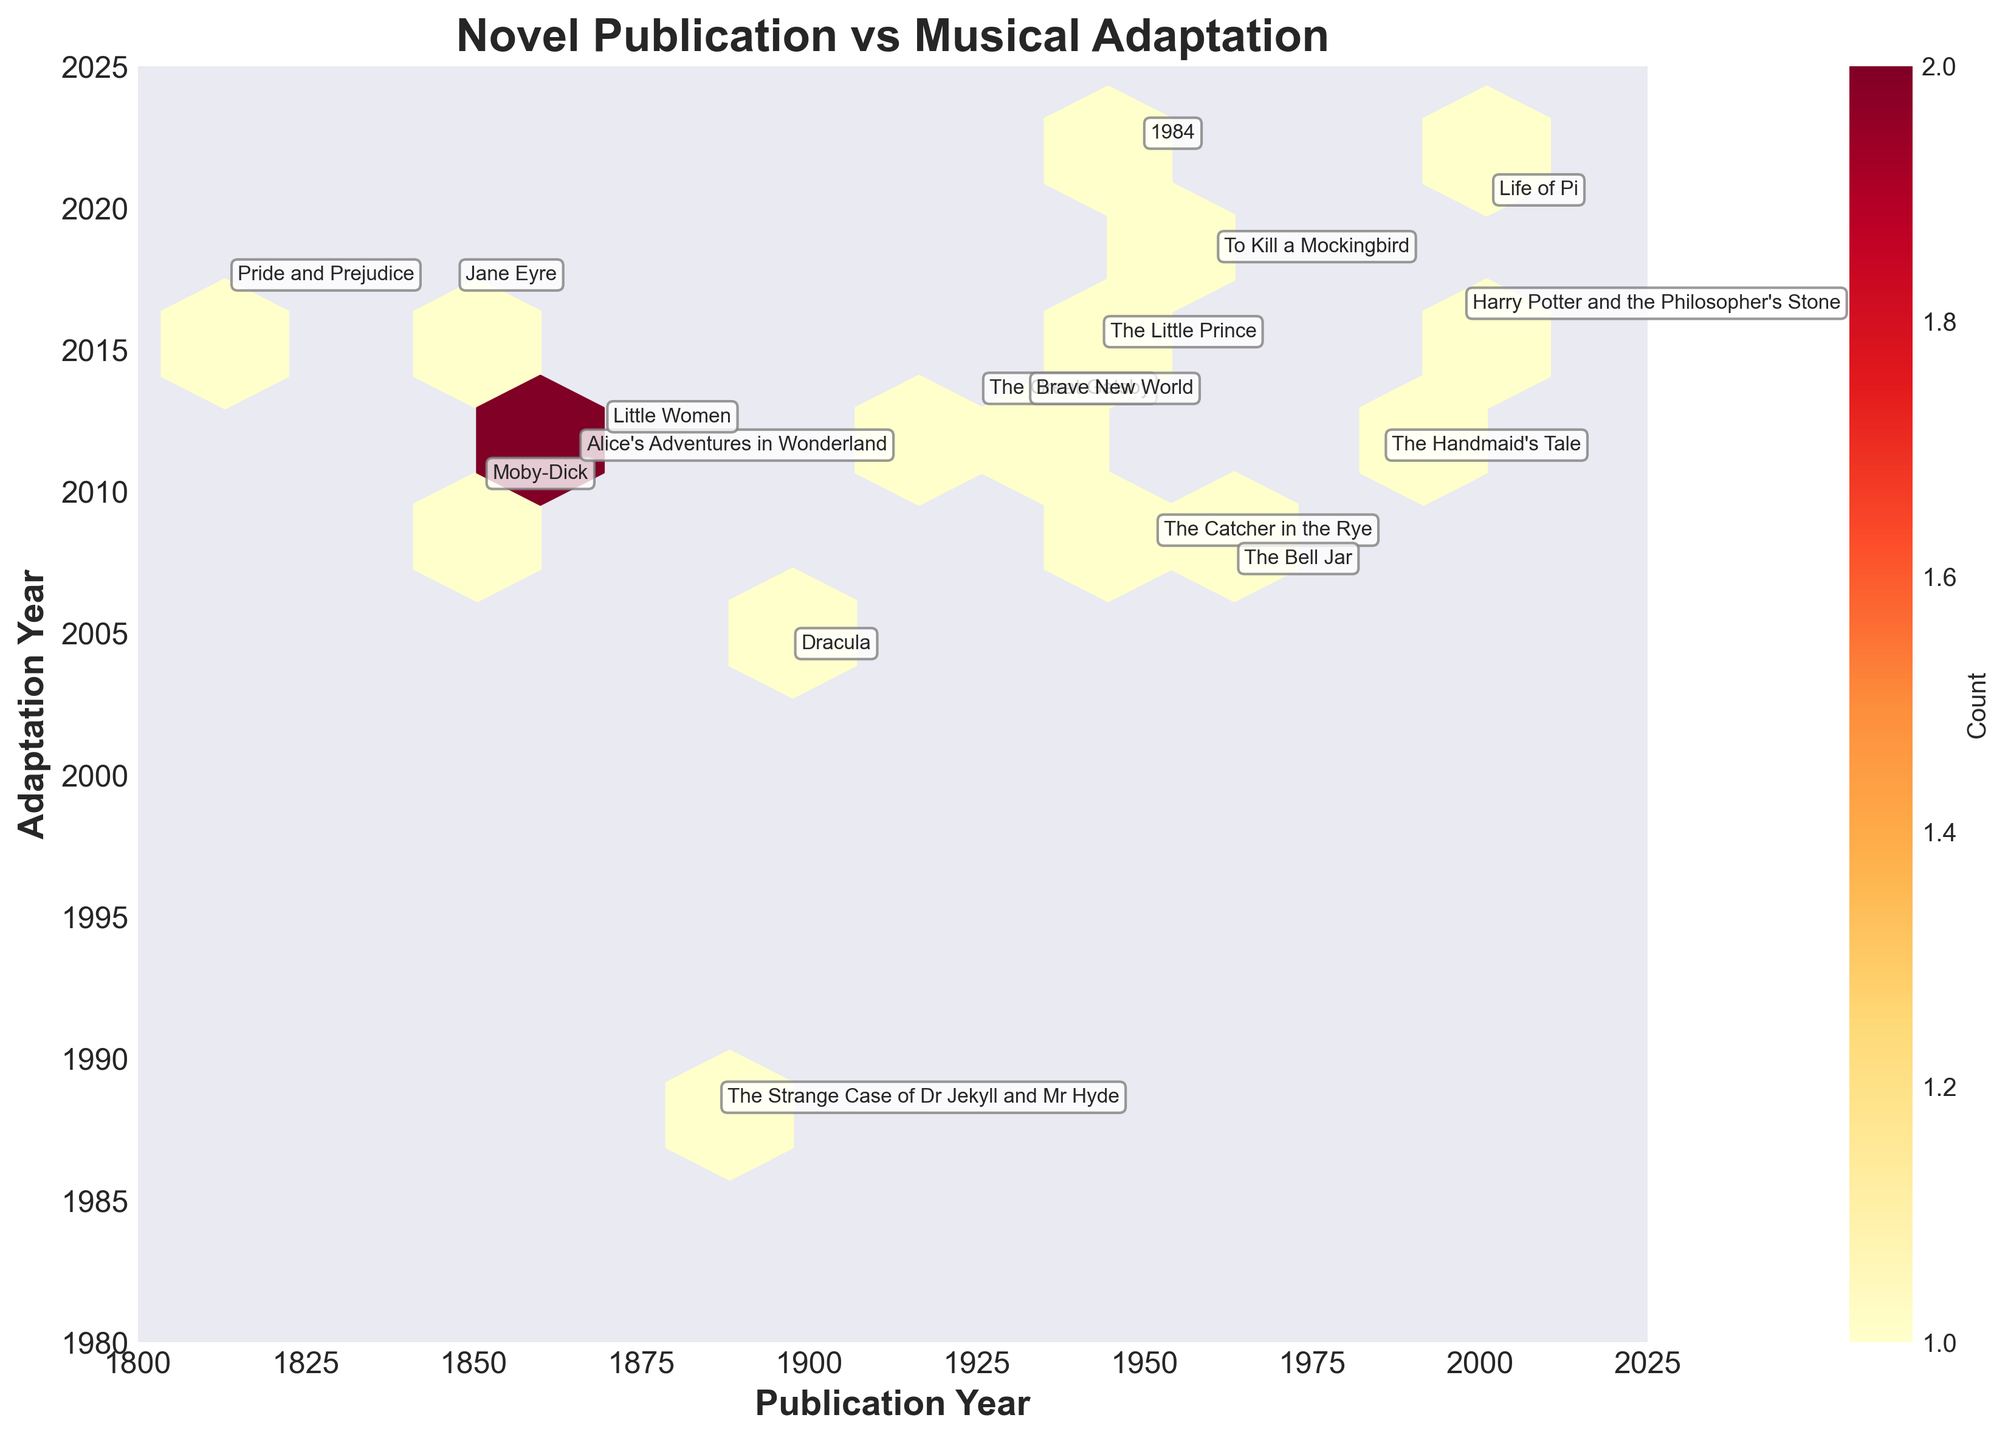What is the title of the hexbin plot? The title of the plot occupies a prominent position above the plot and is typically displayed in a larger, bold font. The title of this specific plot reads "Novel Publication vs Musical Adaptation".
Answer: Novel Publication vs Musical Adaptation How many novels were adapted into musicals in the 21st century? The plot’s y-axis represents the adaptation years. Count the number of data points (hexagons) that fall between the years 2001 and 2023 on the y-axis. There are adaptations for 9 novels in this range.
Answer: 9 Which novel published in the 19th century has the most recent adaptation? Locate the data points for novels published between 1801 and 1900 on the x-axis and check their positions on the y-axis for adaptation years. "Jane Eyre" and "Pride and Prejudice" show the most recent adaptations in 2017.
Answer: Jane Eyre and Pride and Prejudice What is the color of the hexagons representing the highest concentration of data points? The color of each hexagon indicates the density of data points within it, with a color gradient shown in the color bar. The highest concentration typically appears in the darkest colored hexagons, which in this palette would be a dark red.
Answer: Dark red Are there more adaptations done before or after 2010 based on the plot? By observing the distribution of data points along the y-axis, count the number of adaptations before and after 2010. Visual inspection suggests there are more adaptations after 2010.
Answer: After 2010 What is the earliest year a novel from the plot was adapted into a musical? By checking the lower bounds of the y-axis, determine the earliest year shown among the data points. The earliest adaptation year from the plot data is 1988 for "The Strange Case of Dr Jekyll and Mr Hyde".
Answer: 1988 How long did it take on average for the 19th-century novels to be adapted into musicals? Identify the novels published between 1801 and 1900, subtract their publication years from their respective adaptation years, then average these differences. (e.g., 2017-1813 = 204 for "Pride and Prejudice", 2004-1897 = 107 for "Dracula", etc.). A detailed calculation is necessary based on exact numbers.
Answer: Average long duration Was "Harry Potter and the Philosopher's Stone" adapted before or after 2015? Locate "Harry Potter and the Philosopher's Stone" in the plot according to its annotation, then look at its y-axis value. The corresponding musical was adapted in 2016.
Answer: After 2015 Which decade saw the highest number of novel adaptations? Group and count the adaptation years by decades (e.g., 2000-2009, 2010-2019, etc.) and identify which group has the maximum count. From the analysis, the 2010s hold the highest number of adaptations.
Answer: 2010s 